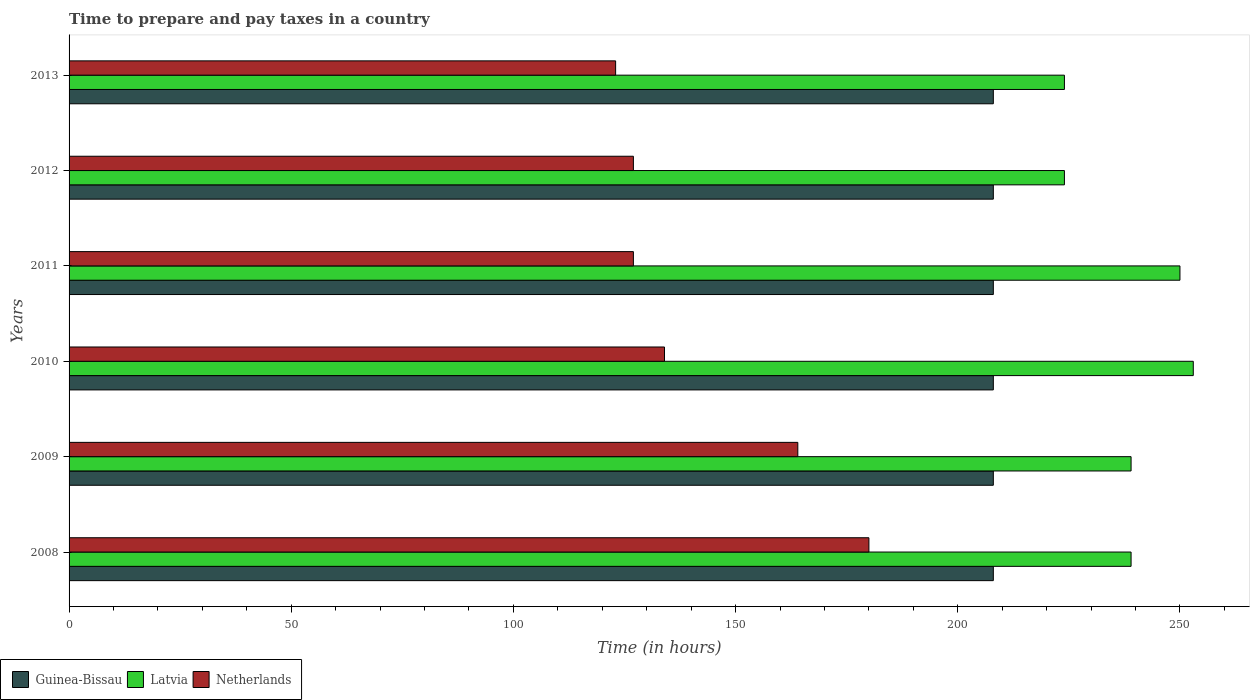How many different coloured bars are there?
Provide a short and direct response. 3. How many groups of bars are there?
Offer a terse response. 6. How many bars are there on the 5th tick from the top?
Keep it short and to the point. 3. How many bars are there on the 2nd tick from the bottom?
Your response must be concise. 3. What is the number of hours required to prepare and pay taxes in Netherlands in 2009?
Offer a terse response. 164. Across all years, what is the maximum number of hours required to prepare and pay taxes in Latvia?
Your response must be concise. 253. Across all years, what is the minimum number of hours required to prepare and pay taxes in Guinea-Bissau?
Keep it short and to the point. 208. In which year was the number of hours required to prepare and pay taxes in Latvia maximum?
Provide a succinct answer. 2010. In which year was the number of hours required to prepare and pay taxes in Latvia minimum?
Provide a short and direct response. 2012. What is the total number of hours required to prepare and pay taxes in Netherlands in the graph?
Give a very brief answer. 855. What is the difference between the number of hours required to prepare and pay taxes in Latvia in 2009 and the number of hours required to prepare and pay taxes in Guinea-Bissau in 2008?
Offer a terse response. 31. What is the average number of hours required to prepare and pay taxes in Netherlands per year?
Offer a very short reply. 142.5. In the year 2010, what is the difference between the number of hours required to prepare and pay taxes in Latvia and number of hours required to prepare and pay taxes in Netherlands?
Provide a succinct answer. 119. In how many years, is the number of hours required to prepare and pay taxes in Latvia greater than 250 hours?
Offer a terse response. 1. What is the ratio of the number of hours required to prepare and pay taxes in Netherlands in 2012 to that in 2013?
Your answer should be compact. 1.03. Is the difference between the number of hours required to prepare and pay taxes in Latvia in 2009 and 2011 greater than the difference between the number of hours required to prepare and pay taxes in Netherlands in 2009 and 2011?
Give a very brief answer. No. Is the sum of the number of hours required to prepare and pay taxes in Latvia in 2012 and 2013 greater than the maximum number of hours required to prepare and pay taxes in Netherlands across all years?
Make the answer very short. Yes. What does the 3rd bar from the top in 2013 represents?
Make the answer very short. Guinea-Bissau. What does the 3rd bar from the bottom in 2011 represents?
Offer a terse response. Netherlands. Is it the case that in every year, the sum of the number of hours required to prepare and pay taxes in Netherlands and number of hours required to prepare and pay taxes in Guinea-Bissau is greater than the number of hours required to prepare and pay taxes in Latvia?
Offer a terse response. Yes. How many bars are there?
Offer a very short reply. 18. Are all the bars in the graph horizontal?
Your answer should be very brief. Yes. Where does the legend appear in the graph?
Offer a terse response. Bottom left. How are the legend labels stacked?
Your response must be concise. Horizontal. What is the title of the graph?
Provide a short and direct response. Time to prepare and pay taxes in a country. Does "Sri Lanka" appear as one of the legend labels in the graph?
Provide a short and direct response. No. What is the label or title of the X-axis?
Offer a very short reply. Time (in hours). What is the label or title of the Y-axis?
Provide a succinct answer. Years. What is the Time (in hours) in Guinea-Bissau in 2008?
Give a very brief answer. 208. What is the Time (in hours) of Latvia in 2008?
Give a very brief answer. 239. What is the Time (in hours) of Netherlands in 2008?
Your answer should be compact. 180. What is the Time (in hours) of Guinea-Bissau in 2009?
Offer a terse response. 208. What is the Time (in hours) of Latvia in 2009?
Give a very brief answer. 239. What is the Time (in hours) in Netherlands in 2009?
Your answer should be very brief. 164. What is the Time (in hours) in Guinea-Bissau in 2010?
Your answer should be very brief. 208. What is the Time (in hours) in Latvia in 2010?
Keep it short and to the point. 253. What is the Time (in hours) of Netherlands in 2010?
Give a very brief answer. 134. What is the Time (in hours) in Guinea-Bissau in 2011?
Give a very brief answer. 208. What is the Time (in hours) in Latvia in 2011?
Offer a terse response. 250. What is the Time (in hours) of Netherlands in 2011?
Offer a terse response. 127. What is the Time (in hours) in Guinea-Bissau in 2012?
Keep it short and to the point. 208. What is the Time (in hours) of Latvia in 2012?
Provide a short and direct response. 224. What is the Time (in hours) of Netherlands in 2012?
Your answer should be very brief. 127. What is the Time (in hours) of Guinea-Bissau in 2013?
Offer a terse response. 208. What is the Time (in hours) of Latvia in 2013?
Make the answer very short. 224. What is the Time (in hours) of Netherlands in 2013?
Keep it short and to the point. 123. Across all years, what is the maximum Time (in hours) of Guinea-Bissau?
Give a very brief answer. 208. Across all years, what is the maximum Time (in hours) of Latvia?
Your answer should be very brief. 253. Across all years, what is the maximum Time (in hours) in Netherlands?
Your answer should be compact. 180. Across all years, what is the minimum Time (in hours) in Guinea-Bissau?
Your answer should be very brief. 208. Across all years, what is the minimum Time (in hours) in Latvia?
Ensure brevity in your answer.  224. Across all years, what is the minimum Time (in hours) of Netherlands?
Give a very brief answer. 123. What is the total Time (in hours) of Guinea-Bissau in the graph?
Your answer should be very brief. 1248. What is the total Time (in hours) of Latvia in the graph?
Keep it short and to the point. 1429. What is the total Time (in hours) in Netherlands in the graph?
Provide a succinct answer. 855. What is the difference between the Time (in hours) of Guinea-Bissau in 2008 and that in 2009?
Ensure brevity in your answer.  0. What is the difference between the Time (in hours) in Guinea-Bissau in 2008 and that in 2010?
Provide a short and direct response. 0. What is the difference between the Time (in hours) in Netherlands in 2008 and that in 2010?
Your answer should be very brief. 46. What is the difference between the Time (in hours) of Guinea-Bissau in 2008 and that in 2011?
Offer a very short reply. 0. What is the difference between the Time (in hours) in Latvia in 2008 and that in 2011?
Offer a terse response. -11. What is the difference between the Time (in hours) of Netherlands in 2008 and that in 2011?
Ensure brevity in your answer.  53. What is the difference between the Time (in hours) in Guinea-Bissau in 2008 and that in 2013?
Offer a very short reply. 0. What is the difference between the Time (in hours) in Netherlands in 2008 and that in 2013?
Offer a very short reply. 57. What is the difference between the Time (in hours) in Latvia in 2009 and that in 2010?
Keep it short and to the point. -14. What is the difference between the Time (in hours) in Latvia in 2009 and that in 2011?
Your answer should be compact. -11. What is the difference between the Time (in hours) of Guinea-Bissau in 2009 and that in 2012?
Your answer should be compact. 0. What is the difference between the Time (in hours) in Latvia in 2009 and that in 2012?
Your answer should be compact. 15. What is the difference between the Time (in hours) in Guinea-Bissau in 2009 and that in 2013?
Provide a short and direct response. 0. What is the difference between the Time (in hours) of Netherlands in 2009 and that in 2013?
Your answer should be very brief. 41. What is the difference between the Time (in hours) of Guinea-Bissau in 2010 and that in 2011?
Provide a short and direct response. 0. What is the difference between the Time (in hours) in Latvia in 2010 and that in 2011?
Ensure brevity in your answer.  3. What is the difference between the Time (in hours) in Netherlands in 2010 and that in 2011?
Provide a succinct answer. 7. What is the difference between the Time (in hours) in Guinea-Bissau in 2010 and that in 2012?
Offer a very short reply. 0. What is the difference between the Time (in hours) in Guinea-Bissau in 2010 and that in 2013?
Provide a succinct answer. 0. What is the difference between the Time (in hours) of Netherlands in 2010 and that in 2013?
Your answer should be compact. 11. What is the difference between the Time (in hours) of Guinea-Bissau in 2011 and that in 2012?
Offer a very short reply. 0. What is the difference between the Time (in hours) of Guinea-Bissau in 2011 and that in 2013?
Your response must be concise. 0. What is the difference between the Time (in hours) in Latvia in 2011 and that in 2013?
Your answer should be compact. 26. What is the difference between the Time (in hours) in Netherlands in 2011 and that in 2013?
Provide a succinct answer. 4. What is the difference between the Time (in hours) in Guinea-Bissau in 2012 and that in 2013?
Your response must be concise. 0. What is the difference between the Time (in hours) in Netherlands in 2012 and that in 2013?
Ensure brevity in your answer.  4. What is the difference between the Time (in hours) in Guinea-Bissau in 2008 and the Time (in hours) in Latvia in 2009?
Your response must be concise. -31. What is the difference between the Time (in hours) of Guinea-Bissau in 2008 and the Time (in hours) of Latvia in 2010?
Your answer should be compact. -45. What is the difference between the Time (in hours) in Guinea-Bissau in 2008 and the Time (in hours) in Netherlands in 2010?
Provide a succinct answer. 74. What is the difference between the Time (in hours) in Latvia in 2008 and the Time (in hours) in Netherlands in 2010?
Make the answer very short. 105. What is the difference between the Time (in hours) in Guinea-Bissau in 2008 and the Time (in hours) in Latvia in 2011?
Give a very brief answer. -42. What is the difference between the Time (in hours) of Latvia in 2008 and the Time (in hours) of Netherlands in 2011?
Ensure brevity in your answer.  112. What is the difference between the Time (in hours) of Guinea-Bissau in 2008 and the Time (in hours) of Netherlands in 2012?
Your answer should be very brief. 81. What is the difference between the Time (in hours) in Latvia in 2008 and the Time (in hours) in Netherlands in 2012?
Make the answer very short. 112. What is the difference between the Time (in hours) in Guinea-Bissau in 2008 and the Time (in hours) in Latvia in 2013?
Keep it short and to the point. -16. What is the difference between the Time (in hours) of Latvia in 2008 and the Time (in hours) of Netherlands in 2013?
Provide a succinct answer. 116. What is the difference between the Time (in hours) of Guinea-Bissau in 2009 and the Time (in hours) of Latvia in 2010?
Your answer should be very brief. -45. What is the difference between the Time (in hours) in Latvia in 2009 and the Time (in hours) in Netherlands in 2010?
Your answer should be compact. 105. What is the difference between the Time (in hours) of Guinea-Bissau in 2009 and the Time (in hours) of Latvia in 2011?
Give a very brief answer. -42. What is the difference between the Time (in hours) in Latvia in 2009 and the Time (in hours) in Netherlands in 2011?
Provide a short and direct response. 112. What is the difference between the Time (in hours) in Latvia in 2009 and the Time (in hours) in Netherlands in 2012?
Your answer should be compact. 112. What is the difference between the Time (in hours) in Guinea-Bissau in 2009 and the Time (in hours) in Latvia in 2013?
Make the answer very short. -16. What is the difference between the Time (in hours) in Latvia in 2009 and the Time (in hours) in Netherlands in 2013?
Offer a terse response. 116. What is the difference between the Time (in hours) of Guinea-Bissau in 2010 and the Time (in hours) of Latvia in 2011?
Keep it short and to the point. -42. What is the difference between the Time (in hours) in Guinea-Bissau in 2010 and the Time (in hours) in Netherlands in 2011?
Ensure brevity in your answer.  81. What is the difference between the Time (in hours) in Latvia in 2010 and the Time (in hours) in Netherlands in 2011?
Your answer should be very brief. 126. What is the difference between the Time (in hours) in Latvia in 2010 and the Time (in hours) in Netherlands in 2012?
Your answer should be compact. 126. What is the difference between the Time (in hours) of Guinea-Bissau in 2010 and the Time (in hours) of Latvia in 2013?
Your answer should be compact. -16. What is the difference between the Time (in hours) of Guinea-Bissau in 2010 and the Time (in hours) of Netherlands in 2013?
Ensure brevity in your answer.  85. What is the difference between the Time (in hours) of Latvia in 2010 and the Time (in hours) of Netherlands in 2013?
Your answer should be compact. 130. What is the difference between the Time (in hours) of Guinea-Bissau in 2011 and the Time (in hours) of Latvia in 2012?
Your answer should be compact. -16. What is the difference between the Time (in hours) in Latvia in 2011 and the Time (in hours) in Netherlands in 2012?
Offer a very short reply. 123. What is the difference between the Time (in hours) in Guinea-Bissau in 2011 and the Time (in hours) in Netherlands in 2013?
Provide a succinct answer. 85. What is the difference between the Time (in hours) in Latvia in 2011 and the Time (in hours) in Netherlands in 2013?
Keep it short and to the point. 127. What is the difference between the Time (in hours) in Guinea-Bissau in 2012 and the Time (in hours) in Latvia in 2013?
Offer a terse response. -16. What is the difference between the Time (in hours) in Latvia in 2012 and the Time (in hours) in Netherlands in 2013?
Your answer should be compact. 101. What is the average Time (in hours) of Guinea-Bissau per year?
Your answer should be very brief. 208. What is the average Time (in hours) in Latvia per year?
Make the answer very short. 238.17. What is the average Time (in hours) in Netherlands per year?
Ensure brevity in your answer.  142.5. In the year 2008, what is the difference between the Time (in hours) of Guinea-Bissau and Time (in hours) of Latvia?
Ensure brevity in your answer.  -31. In the year 2008, what is the difference between the Time (in hours) of Latvia and Time (in hours) of Netherlands?
Provide a short and direct response. 59. In the year 2009, what is the difference between the Time (in hours) of Guinea-Bissau and Time (in hours) of Latvia?
Provide a succinct answer. -31. In the year 2009, what is the difference between the Time (in hours) of Guinea-Bissau and Time (in hours) of Netherlands?
Make the answer very short. 44. In the year 2009, what is the difference between the Time (in hours) of Latvia and Time (in hours) of Netherlands?
Your response must be concise. 75. In the year 2010, what is the difference between the Time (in hours) in Guinea-Bissau and Time (in hours) in Latvia?
Your response must be concise. -45. In the year 2010, what is the difference between the Time (in hours) of Latvia and Time (in hours) of Netherlands?
Keep it short and to the point. 119. In the year 2011, what is the difference between the Time (in hours) in Guinea-Bissau and Time (in hours) in Latvia?
Make the answer very short. -42. In the year 2011, what is the difference between the Time (in hours) of Guinea-Bissau and Time (in hours) of Netherlands?
Your response must be concise. 81. In the year 2011, what is the difference between the Time (in hours) in Latvia and Time (in hours) in Netherlands?
Ensure brevity in your answer.  123. In the year 2012, what is the difference between the Time (in hours) of Latvia and Time (in hours) of Netherlands?
Offer a very short reply. 97. In the year 2013, what is the difference between the Time (in hours) of Latvia and Time (in hours) of Netherlands?
Provide a succinct answer. 101. What is the ratio of the Time (in hours) in Netherlands in 2008 to that in 2009?
Your answer should be very brief. 1.1. What is the ratio of the Time (in hours) in Latvia in 2008 to that in 2010?
Your answer should be compact. 0.94. What is the ratio of the Time (in hours) of Netherlands in 2008 to that in 2010?
Your answer should be very brief. 1.34. What is the ratio of the Time (in hours) of Guinea-Bissau in 2008 to that in 2011?
Ensure brevity in your answer.  1. What is the ratio of the Time (in hours) of Latvia in 2008 to that in 2011?
Offer a very short reply. 0.96. What is the ratio of the Time (in hours) of Netherlands in 2008 to that in 2011?
Make the answer very short. 1.42. What is the ratio of the Time (in hours) in Latvia in 2008 to that in 2012?
Give a very brief answer. 1.07. What is the ratio of the Time (in hours) of Netherlands in 2008 to that in 2012?
Your answer should be very brief. 1.42. What is the ratio of the Time (in hours) of Latvia in 2008 to that in 2013?
Your answer should be compact. 1.07. What is the ratio of the Time (in hours) of Netherlands in 2008 to that in 2013?
Your answer should be very brief. 1.46. What is the ratio of the Time (in hours) in Latvia in 2009 to that in 2010?
Keep it short and to the point. 0.94. What is the ratio of the Time (in hours) of Netherlands in 2009 to that in 2010?
Your response must be concise. 1.22. What is the ratio of the Time (in hours) in Latvia in 2009 to that in 2011?
Your answer should be very brief. 0.96. What is the ratio of the Time (in hours) of Netherlands in 2009 to that in 2011?
Provide a short and direct response. 1.29. What is the ratio of the Time (in hours) in Latvia in 2009 to that in 2012?
Offer a very short reply. 1.07. What is the ratio of the Time (in hours) in Netherlands in 2009 to that in 2012?
Your answer should be very brief. 1.29. What is the ratio of the Time (in hours) of Latvia in 2009 to that in 2013?
Make the answer very short. 1.07. What is the ratio of the Time (in hours) in Netherlands in 2010 to that in 2011?
Your answer should be compact. 1.06. What is the ratio of the Time (in hours) in Latvia in 2010 to that in 2012?
Make the answer very short. 1.13. What is the ratio of the Time (in hours) of Netherlands in 2010 to that in 2012?
Your answer should be very brief. 1.06. What is the ratio of the Time (in hours) in Guinea-Bissau in 2010 to that in 2013?
Make the answer very short. 1. What is the ratio of the Time (in hours) of Latvia in 2010 to that in 2013?
Provide a succinct answer. 1.13. What is the ratio of the Time (in hours) in Netherlands in 2010 to that in 2013?
Give a very brief answer. 1.09. What is the ratio of the Time (in hours) in Latvia in 2011 to that in 2012?
Keep it short and to the point. 1.12. What is the ratio of the Time (in hours) of Guinea-Bissau in 2011 to that in 2013?
Ensure brevity in your answer.  1. What is the ratio of the Time (in hours) in Latvia in 2011 to that in 2013?
Keep it short and to the point. 1.12. What is the ratio of the Time (in hours) in Netherlands in 2011 to that in 2013?
Offer a terse response. 1.03. What is the ratio of the Time (in hours) in Guinea-Bissau in 2012 to that in 2013?
Make the answer very short. 1. What is the ratio of the Time (in hours) of Latvia in 2012 to that in 2013?
Provide a short and direct response. 1. What is the ratio of the Time (in hours) of Netherlands in 2012 to that in 2013?
Keep it short and to the point. 1.03. What is the difference between the highest and the second highest Time (in hours) of Latvia?
Give a very brief answer. 3. What is the difference between the highest and the second highest Time (in hours) of Netherlands?
Give a very brief answer. 16. What is the difference between the highest and the lowest Time (in hours) in Netherlands?
Make the answer very short. 57. 